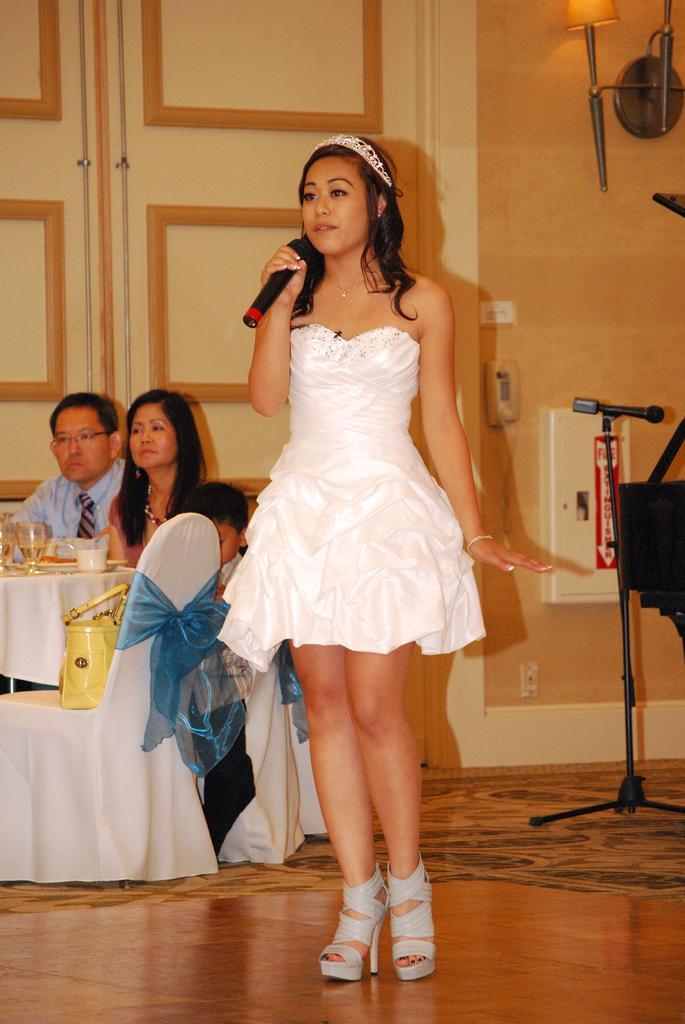In one or two sentences, can you explain what this image depicts? This is an inside view. Here I can see a woman wearing white color frock, standing and holding a mike in the hand. It seems like she is speaking something. On the right side there is a mike stand and a metal object is attached to the wall. On the left side I can see a table which is covered with a white color cloth. Around this table few people are sitting on the chairs. On the table I can see few glasses. In the background there is a door. 